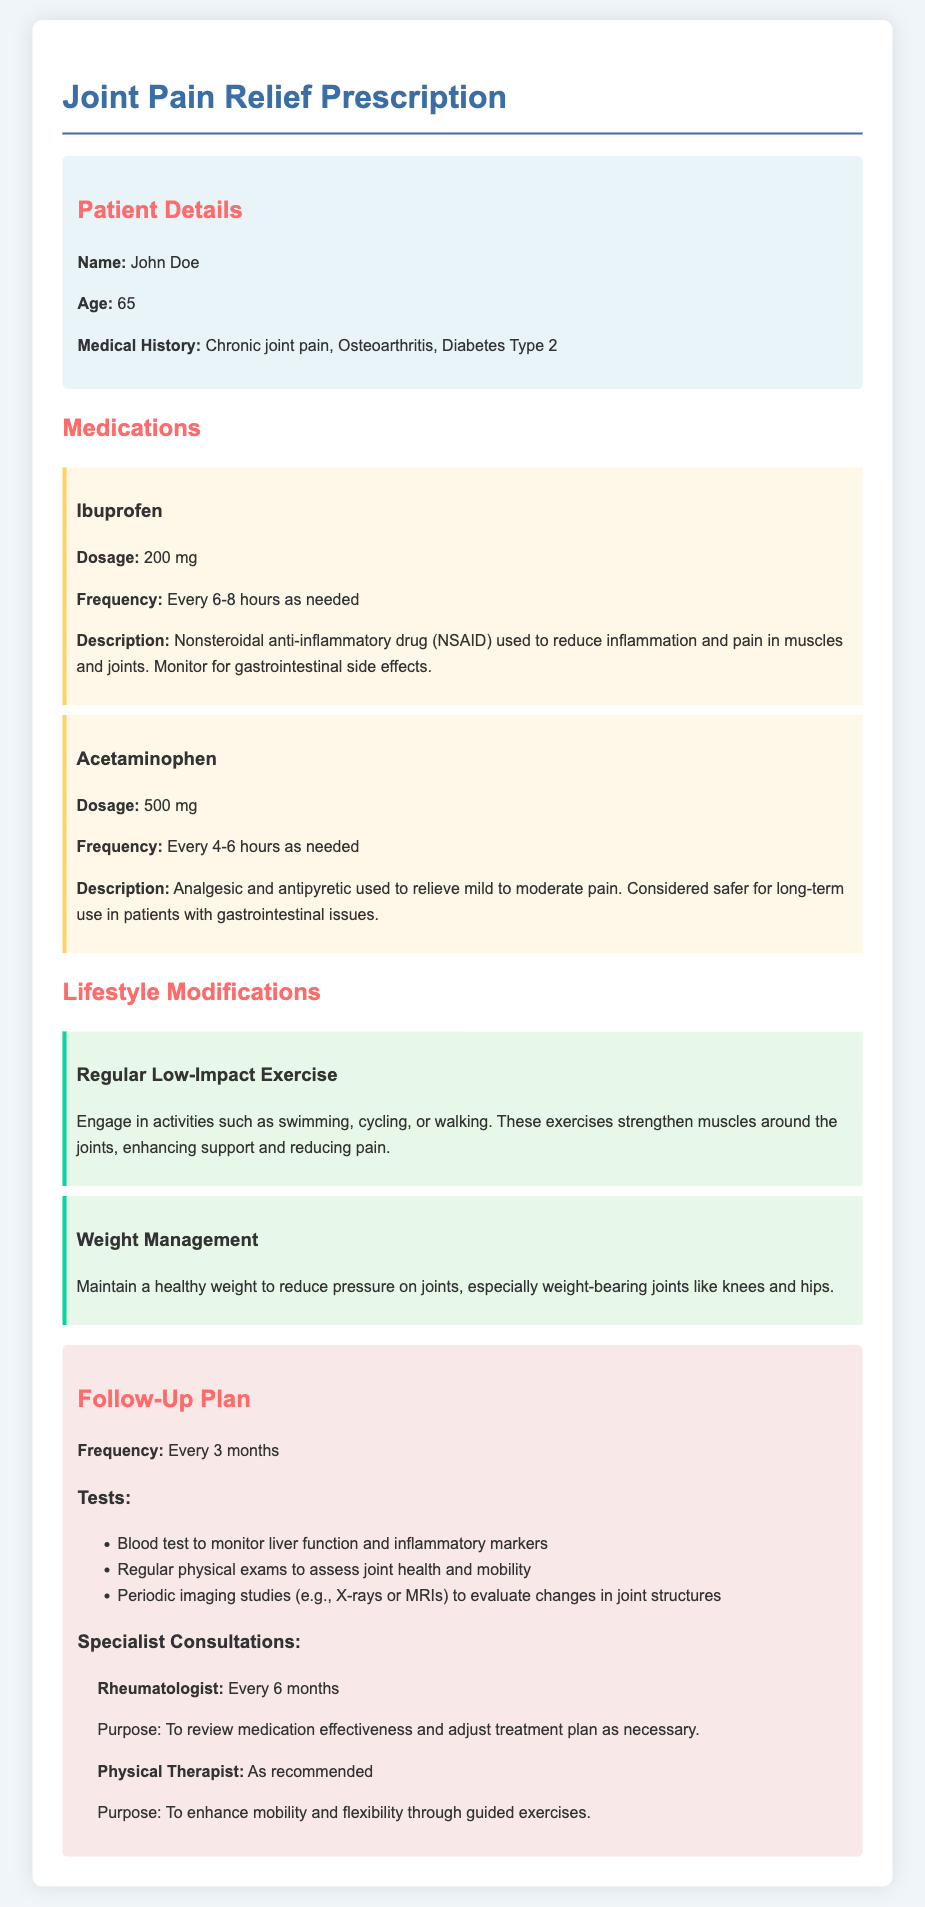What is the patient's name? The patient's name is listed in the patient details section of the document.
Answer: John Doe What is the age of the patient? The patient's age is included in the patient details section.
Answer: 65 What is the prescribed medication for pain relief? The document lists two medications prescribed for pain relief.
Answer: Ibuprofen and Acetaminophen What is the dosage of Ibuprofen? The dosage for Ibuprofen can be found in the medications section of the document.
Answer: 200 mg How often should Acetaminophen be taken? The document provides the frequency for taking Acetaminophen.
Answer: Every 4-6 hours as needed What lifestyle modification is recommended for exercise? The lifestyle modifications section describes the type of exercise recommended.
Answer: Regular Low-Impact Exercise How often should follow-up visits occur? The follow-up plan section specifies the frequency of these visits.
Answer: Every 3 months Who should the patient consult every six months? The document provides information about consultations needed by the patient.
Answer: Rheumatologist What type of tests are included in the follow-up plan? The document lists several tests as part of the follow-up plan.
Answer: Blood test to monitor liver function and inflammatory markers What is the purpose of seeing a Physical Therapist? The document states the reason for consulting a Physical Therapist.
Answer: To enhance mobility and flexibility through guided exercises 